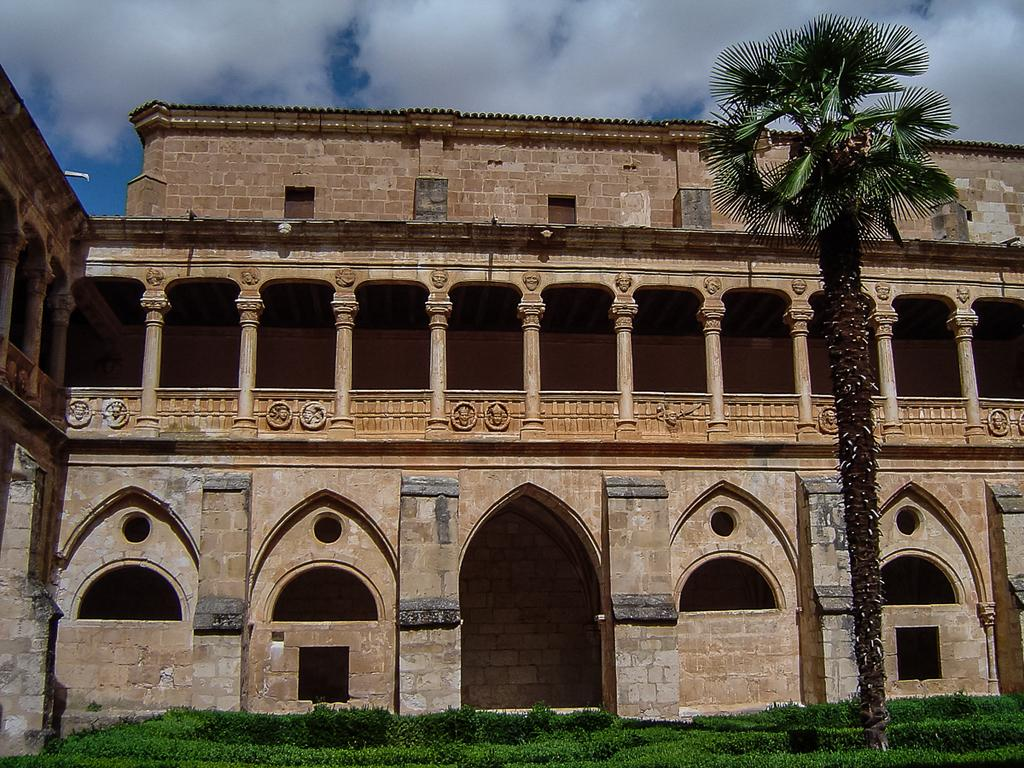What type of structure is present in the image? There is a building in the image. What architectural features can be seen on the building? Some pillars are visible in the image. What type of vegetation is present in the image? There are plants and a tree in the image. What can be seen in the background of the image? The sky is visible in the image. How does the building's wealth affect the plants in the image? The image does not provide any information about the building's wealth, so it cannot be determined how it might affect the plants. 